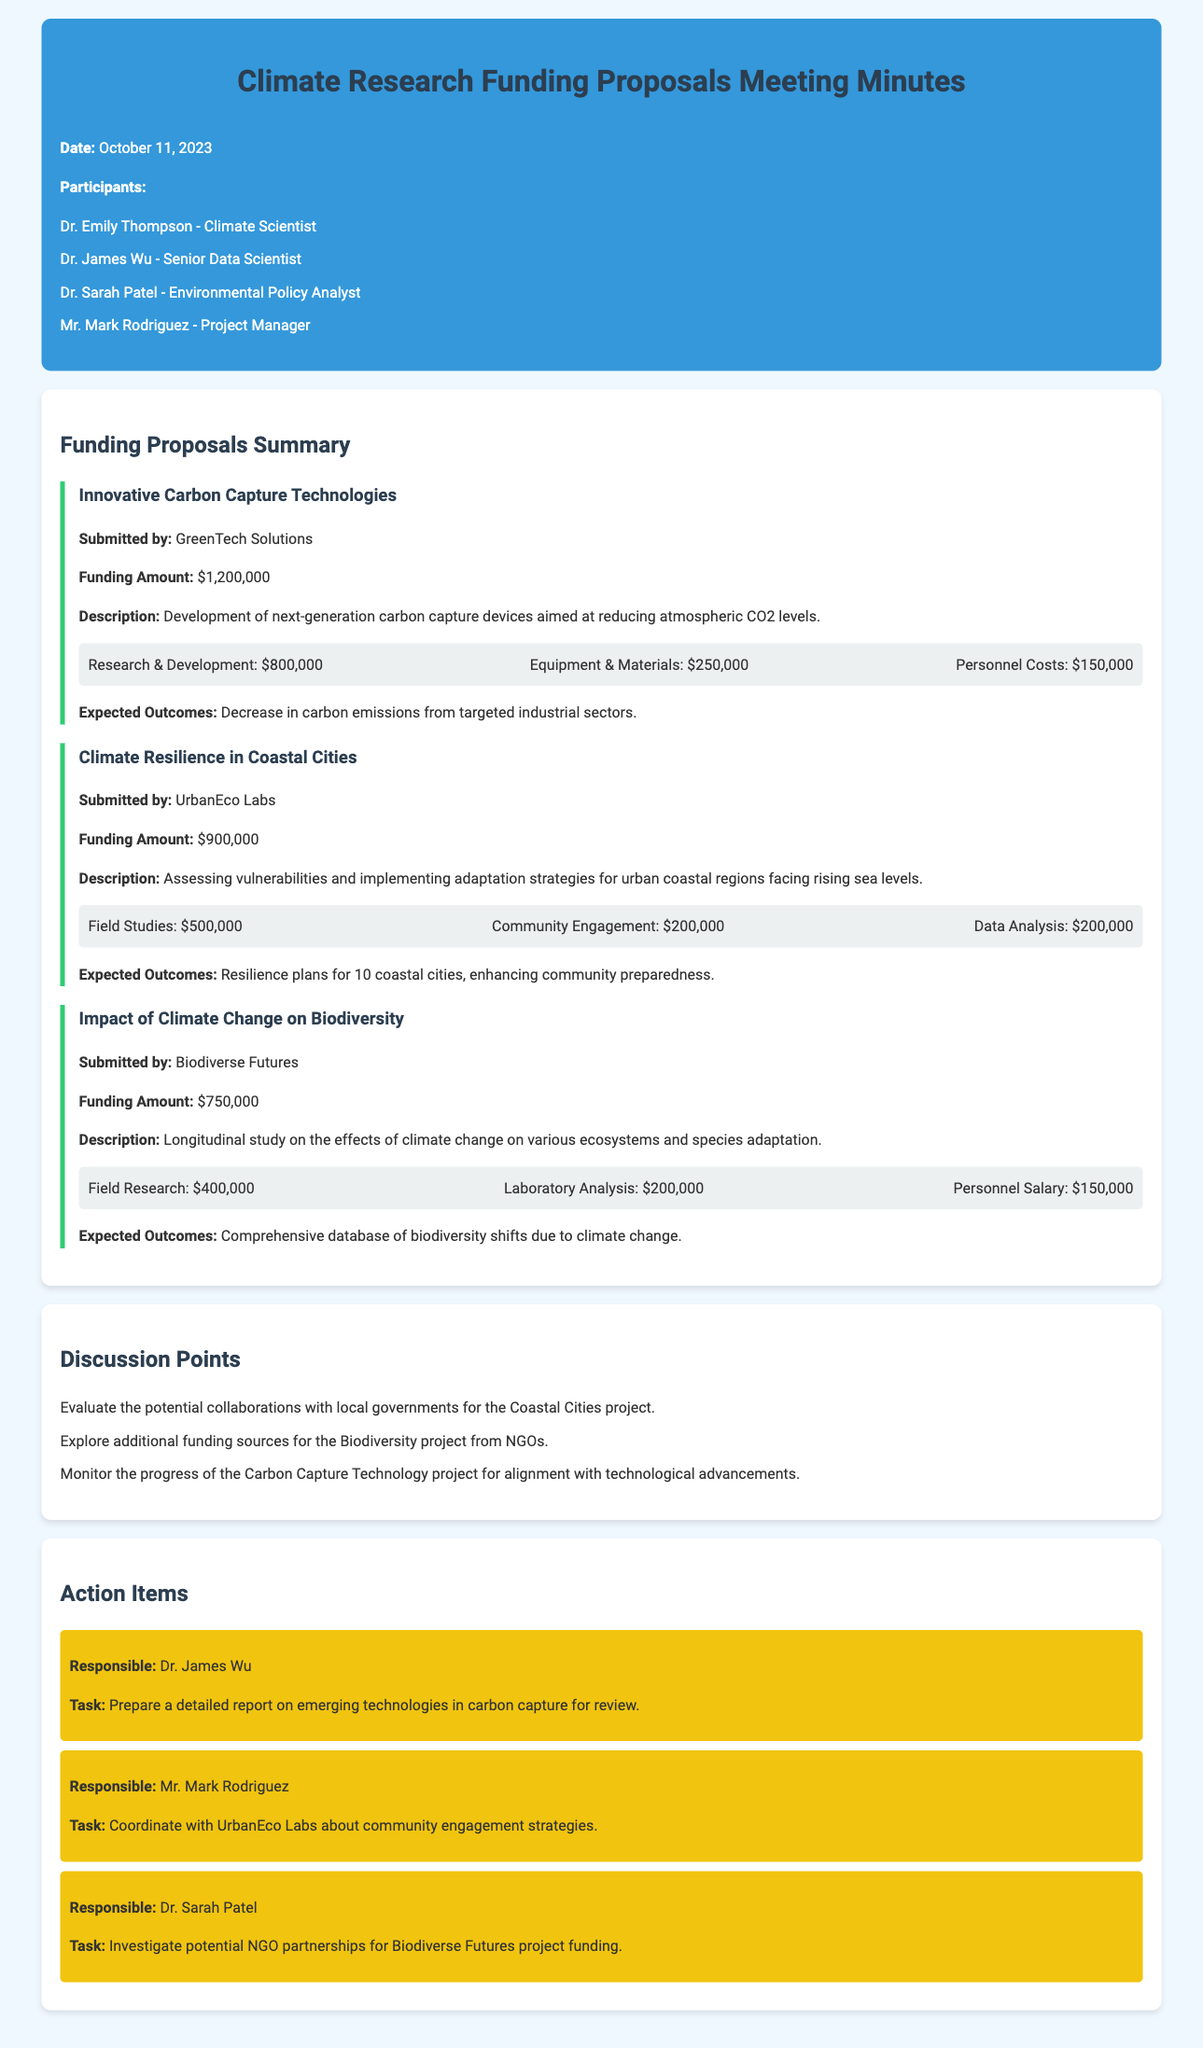What is the date of the meeting? The date of the meeting is mentioned at the start of the document.
Answer: October 11, 2023 Who submitted the proposal for Innovative Carbon Capture Technologies? The document states the organization that submitted the proposal.
Answer: GreenTech Solutions What is the funding amount for the Climate Resilience in Coastal Cities project? The funding amount is detailed under the project description section.
Answer: $900,000 What is the expected outcome of the Impact of Climate Change on Biodiversity project? The expected outcome for this project is listed in the description.
Answer: Comprehensive database of biodiversity shifts due to climate change How much budget is allocated for Personnel Costs in the Carbon Capture project? The document specifies individual budget allocations for each area within the project.
Answer: $150,000 Which individual is responsible for investigating potential NGO partnerships for the Biodiverse Futures project funding? The action items section lists responsibilities assigned to individuals.
Answer: Dr. Sarah Patel What is the total funding amount requested for all three proposals? The total amount can be calculated by summing the individual funding amounts for each proposal.
Answer: $2,850,000 Which aspect of the Coastal Cities project ought to be evaluated for potential collaborations? The discussion points provide insights about areas of collaboration or investigation.
Answer: Local governments What is the main task assigned to Mr. Mark Rodriguez? The action items section outlines the specific tasks for each participant.
Answer: Coordinate with UrbanEco Labs about community engagement strategies 